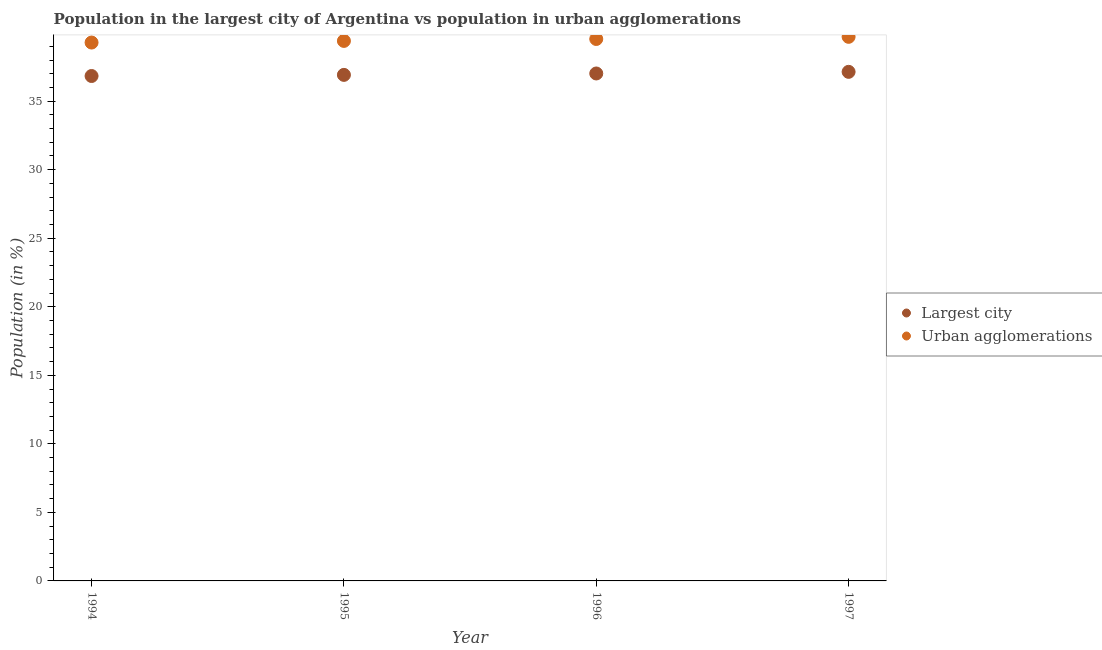Is the number of dotlines equal to the number of legend labels?
Offer a terse response. Yes. What is the population in the largest city in 1996?
Your response must be concise. 37.02. Across all years, what is the maximum population in urban agglomerations?
Provide a succinct answer. 39.69. Across all years, what is the minimum population in urban agglomerations?
Provide a succinct answer. 39.27. In which year was the population in the largest city maximum?
Keep it short and to the point. 1997. In which year was the population in urban agglomerations minimum?
Provide a short and direct response. 1994. What is the total population in the largest city in the graph?
Provide a short and direct response. 147.9. What is the difference between the population in urban agglomerations in 1994 and that in 1997?
Give a very brief answer. -0.42. What is the difference between the population in urban agglomerations in 1996 and the population in the largest city in 1995?
Your response must be concise. 2.62. What is the average population in urban agglomerations per year?
Give a very brief answer. 39.47. In the year 1996, what is the difference between the population in the largest city and population in urban agglomerations?
Offer a very short reply. -2.52. In how many years, is the population in urban agglomerations greater than 22 %?
Offer a very short reply. 4. What is the ratio of the population in the largest city in 1994 to that in 1997?
Your answer should be compact. 0.99. What is the difference between the highest and the second highest population in the largest city?
Your answer should be compact. 0.12. What is the difference between the highest and the lowest population in the largest city?
Offer a terse response. 0.3. Is the sum of the population in urban agglomerations in 1996 and 1997 greater than the maximum population in the largest city across all years?
Your answer should be compact. Yes. Does the population in urban agglomerations monotonically increase over the years?
Keep it short and to the point. Yes. Is the population in urban agglomerations strictly greater than the population in the largest city over the years?
Make the answer very short. Yes. How many dotlines are there?
Ensure brevity in your answer.  2. How many years are there in the graph?
Give a very brief answer. 4. What is the difference between two consecutive major ticks on the Y-axis?
Keep it short and to the point. 5. Are the values on the major ticks of Y-axis written in scientific E-notation?
Ensure brevity in your answer.  No. Does the graph contain grids?
Keep it short and to the point. No. How many legend labels are there?
Your answer should be very brief. 2. What is the title of the graph?
Your answer should be compact. Population in the largest city of Argentina vs population in urban agglomerations. What is the label or title of the Y-axis?
Offer a terse response. Population (in %). What is the Population (in %) of Largest city in 1994?
Ensure brevity in your answer.  36.83. What is the Population (in %) in Urban agglomerations in 1994?
Provide a short and direct response. 39.27. What is the Population (in %) in Largest city in 1995?
Offer a very short reply. 36.92. What is the Population (in %) of Urban agglomerations in 1995?
Your response must be concise. 39.39. What is the Population (in %) of Largest city in 1996?
Ensure brevity in your answer.  37.02. What is the Population (in %) of Urban agglomerations in 1996?
Provide a short and direct response. 39.53. What is the Population (in %) in Largest city in 1997?
Keep it short and to the point. 37.14. What is the Population (in %) of Urban agglomerations in 1997?
Your answer should be very brief. 39.69. Across all years, what is the maximum Population (in %) in Largest city?
Your response must be concise. 37.14. Across all years, what is the maximum Population (in %) of Urban agglomerations?
Provide a succinct answer. 39.69. Across all years, what is the minimum Population (in %) of Largest city?
Make the answer very short. 36.83. Across all years, what is the minimum Population (in %) in Urban agglomerations?
Offer a very short reply. 39.27. What is the total Population (in %) in Largest city in the graph?
Make the answer very short. 147.9. What is the total Population (in %) of Urban agglomerations in the graph?
Offer a very short reply. 157.89. What is the difference between the Population (in %) of Largest city in 1994 and that in 1995?
Your response must be concise. -0.08. What is the difference between the Population (in %) of Urban agglomerations in 1994 and that in 1995?
Offer a very short reply. -0.12. What is the difference between the Population (in %) of Largest city in 1994 and that in 1996?
Your answer should be very brief. -0.18. What is the difference between the Population (in %) in Urban agglomerations in 1994 and that in 1996?
Provide a succinct answer. -0.26. What is the difference between the Population (in %) of Largest city in 1994 and that in 1997?
Make the answer very short. -0.3. What is the difference between the Population (in %) in Urban agglomerations in 1994 and that in 1997?
Your answer should be compact. -0.42. What is the difference between the Population (in %) of Largest city in 1995 and that in 1996?
Your answer should be compact. -0.1. What is the difference between the Population (in %) of Urban agglomerations in 1995 and that in 1996?
Provide a short and direct response. -0.14. What is the difference between the Population (in %) in Largest city in 1995 and that in 1997?
Offer a very short reply. -0.22. What is the difference between the Population (in %) of Urban agglomerations in 1995 and that in 1997?
Your answer should be very brief. -0.3. What is the difference between the Population (in %) in Largest city in 1996 and that in 1997?
Keep it short and to the point. -0.12. What is the difference between the Population (in %) in Urban agglomerations in 1996 and that in 1997?
Offer a terse response. -0.16. What is the difference between the Population (in %) of Largest city in 1994 and the Population (in %) of Urban agglomerations in 1995?
Provide a short and direct response. -2.56. What is the difference between the Population (in %) in Largest city in 1994 and the Population (in %) in Urban agglomerations in 1996?
Give a very brief answer. -2.7. What is the difference between the Population (in %) in Largest city in 1994 and the Population (in %) in Urban agglomerations in 1997?
Your answer should be very brief. -2.86. What is the difference between the Population (in %) in Largest city in 1995 and the Population (in %) in Urban agglomerations in 1996?
Give a very brief answer. -2.62. What is the difference between the Population (in %) in Largest city in 1995 and the Population (in %) in Urban agglomerations in 1997?
Offer a terse response. -2.78. What is the difference between the Population (in %) of Largest city in 1996 and the Population (in %) of Urban agglomerations in 1997?
Keep it short and to the point. -2.67. What is the average Population (in %) in Largest city per year?
Your answer should be very brief. 36.98. What is the average Population (in %) of Urban agglomerations per year?
Your response must be concise. 39.47. In the year 1994, what is the difference between the Population (in %) of Largest city and Population (in %) of Urban agglomerations?
Provide a short and direct response. -2.44. In the year 1995, what is the difference between the Population (in %) of Largest city and Population (in %) of Urban agglomerations?
Offer a terse response. -2.48. In the year 1996, what is the difference between the Population (in %) in Largest city and Population (in %) in Urban agglomerations?
Ensure brevity in your answer.  -2.52. In the year 1997, what is the difference between the Population (in %) of Largest city and Population (in %) of Urban agglomerations?
Ensure brevity in your answer.  -2.55. What is the ratio of the Population (in %) in Largest city in 1994 to that in 1995?
Your response must be concise. 1. What is the ratio of the Population (in %) of Urban agglomerations in 1994 to that in 1995?
Offer a very short reply. 1. What is the ratio of the Population (in %) of Largest city in 1994 to that in 1997?
Your answer should be compact. 0.99. What is the ratio of the Population (in %) in Urban agglomerations in 1994 to that in 1997?
Make the answer very short. 0.99. What is the ratio of the Population (in %) in Largest city in 1995 to that in 1996?
Provide a short and direct response. 1. What is the ratio of the Population (in %) in Urban agglomerations in 1996 to that in 1997?
Your answer should be compact. 1. What is the difference between the highest and the second highest Population (in %) in Largest city?
Provide a succinct answer. 0.12. What is the difference between the highest and the second highest Population (in %) of Urban agglomerations?
Keep it short and to the point. 0.16. What is the difference between the highest and the lowest Population (in %) in Largest city?
Offer a terse response. 0.3. What is the difference between the highest and the lowest Population (in %) of Urban agglomerations?
Your answer should be compact. 0.42. 